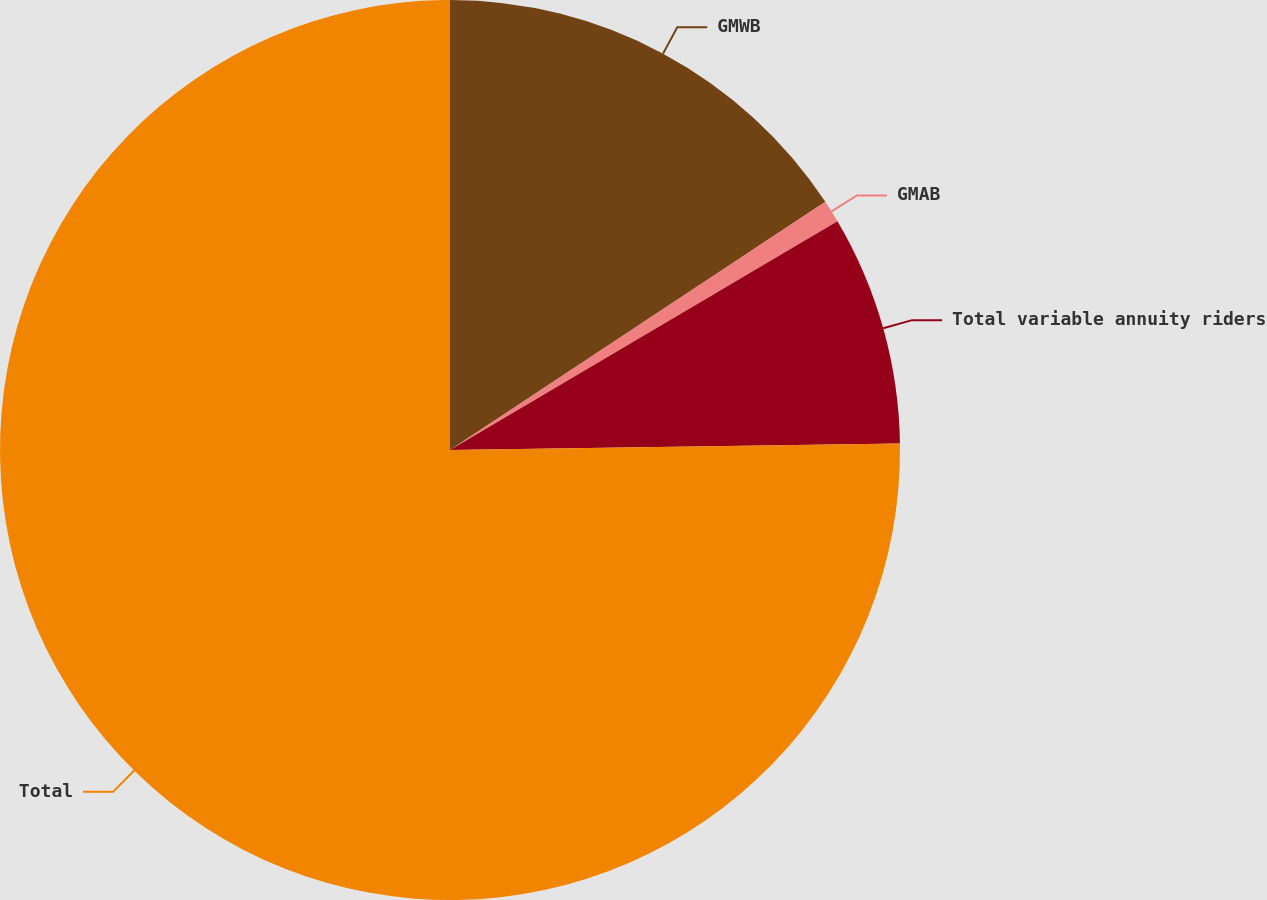Convert chart to OTSL. <chart><loc_0><loc_0><loc_500><loc_500><pie_chart><fcel>GMWB<fcel>GMAB<fcel>Total variable annuity riders<fcel>Total<nl><fcel>15.7%<fcel>0.81%<fcel>8.26%<fcel>75.23%<nl></chart> 